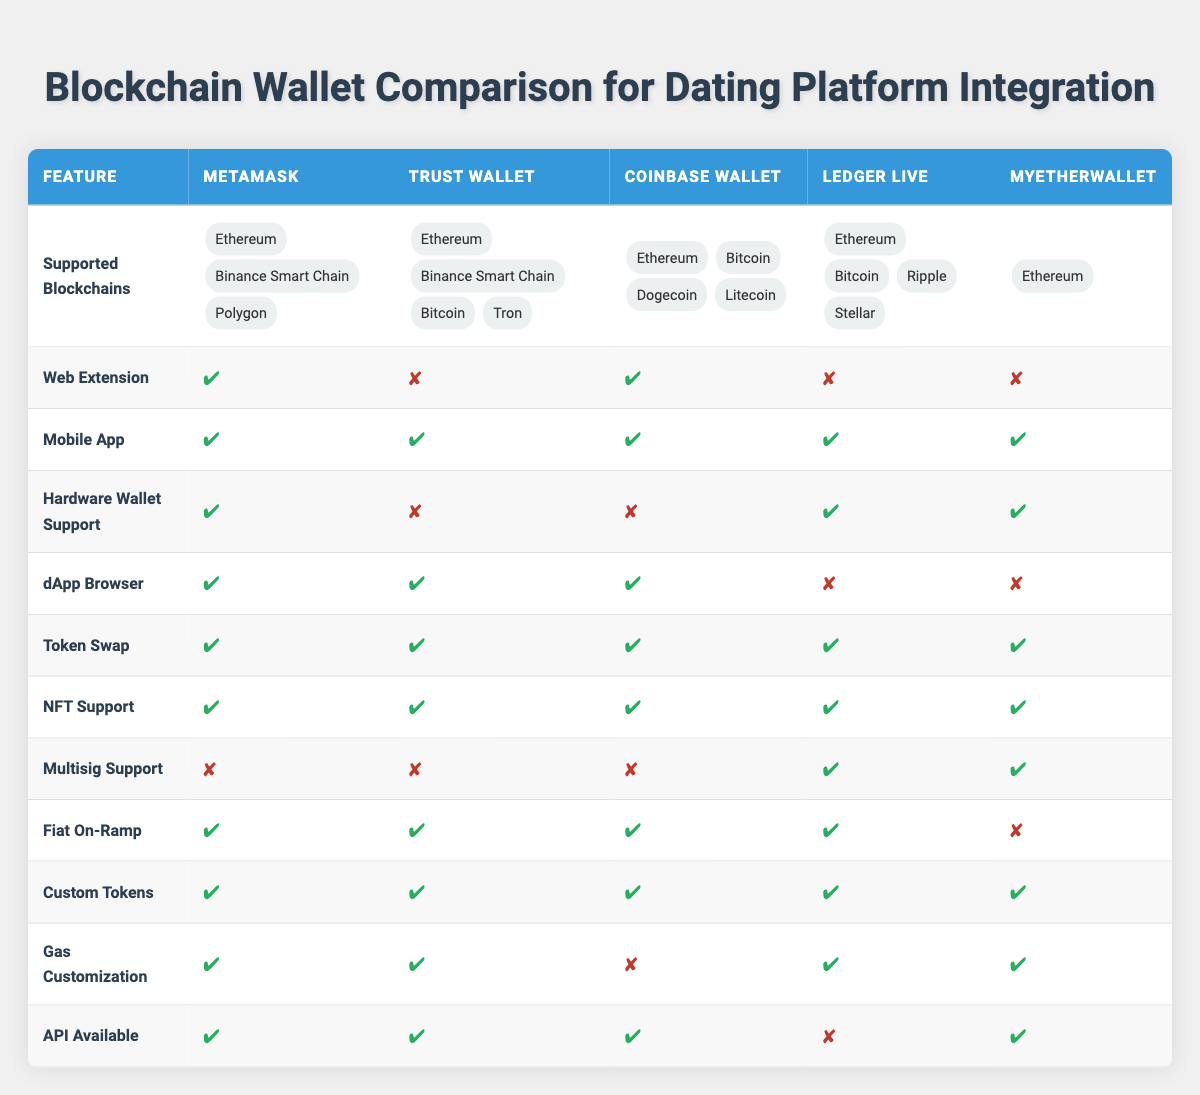Which wallet supports the most blockchains? By reviewing the "Supported Blockchains" row for each wallet, we can count the number of blockchains each supports. MetaMask supports 3 blockchains (Ethereum, Binance Smart Chain, Polygon), Trust Wallet supports 4 (Ethereum, Binance Smart Chain, Bitcoin, Tron), Coinbase Wallet supports 4 (Ethereum, Bitcoin, Dogecoin, Litecoin), Ledger Live supports 4 (Ethereum, Bitcoin, Ripple, Stellar), and MyEtherWallet supports 1 (Ethereum). Therefore, Trust Wallet, Coinbase Wallet, and Ledger Live are tied for supporting the most blockchains.
Answer: Trust Wallet, Coinbase Wallet, and Ledger Live Does MetaMask have hardware wallet support? The table indicates that MetaMask has hardware wallet support, as shown in the "Hardware Wallet Support" row where the value is a checkmark (✔).
Answer: Yes Which wallets have an API available? By checking the "API Available" row, we see that MetaMask, Trust Wallet, Coinbase Wallet, and MyEtherWallet all have the API available, as indicated by the checkmarks (✔). Ledger Live does not have it, as shown by the cross (✘).
Answer: MetaMask, Trust Wallet, Coinbase Wallet, MyEtherWallet Which feature is unique to Ledger Live when compared to MyEtherWallet? In the table, by examining the "Multisig Support" row, we find that Ledger Live supports multisig (✔), while MyEtherWallet also supports it (✔). However, Ledger Live has hardware wallet support and MyEtherWallet does too, so neither is unique in that respect. The only row where Ledger Live is not matched is in the "API Available" row where it is marked as not having it (✘). So, the unique aspect of Ledger Live compared to MyEtherWallet is that it has hardware wallet support.
Answer: None Which wallet does not offer a fiat on-ramp? The "Fiat On-Ramp" row shows that only MyEtherWallet does not support this feature, as indicated by the cross (✘). All other wallets have a checkmark (✔), meaning they support fiat on-ramping.
Answer: MyEtherWallet How many wallets provide gas customization features? Looking at the "Gas Customization" row, we see that MetaMask, Trust Wallet, Ledger Live, and MyEtherWallet all have gas customization, as indicated by the checkmarks (✔). Coinbase Wallet does not have this feature, as shown by the cross (✘). Therefore, we can conclude that there are 4 wallets that provide this feature.
Answer: 4 Do all wallets support NFT functionality? From the "NFT Support" row, we see that every wallet has this feature available, as indicated by the checkmarks (✔) next to each wallet.
Answer: Yes Which wallet has web extension support, but not hardware wallet support? When we analyze the "Web Extension" and "Hardware Wallet Support" rows, we note that Coinbase Wallet has web extension support (✔) and does not have hardware wallet support (✘). Thus, this wallet fits the criteria perfectly.
Answer: Coinbase Wallet 